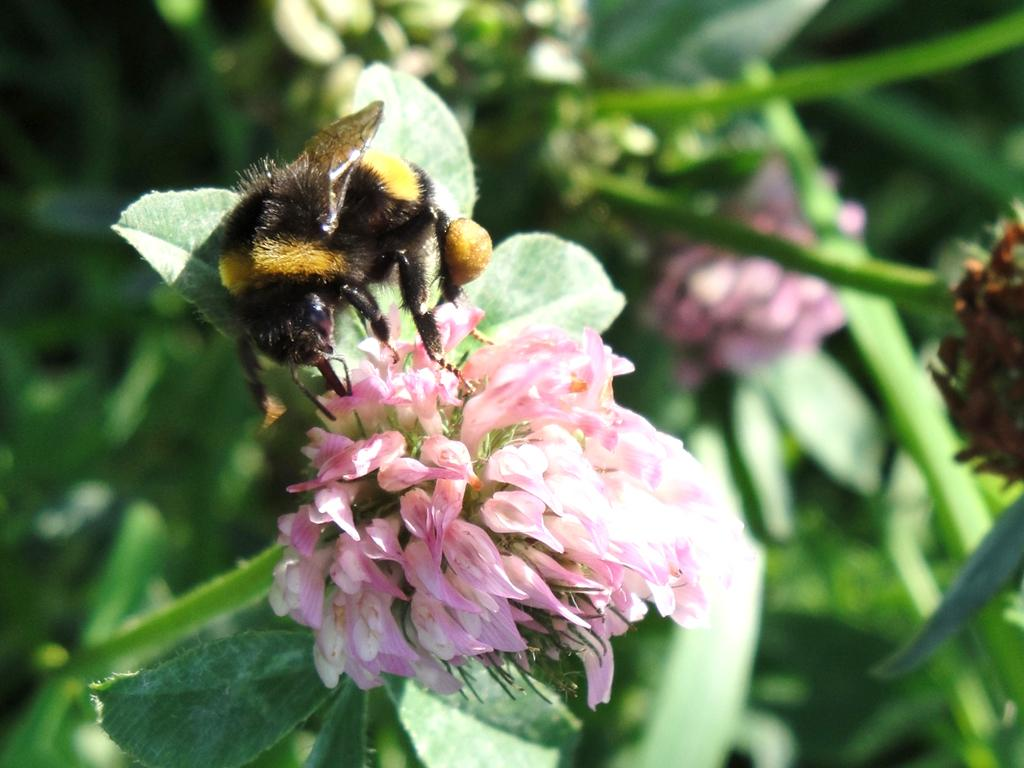What type of plants can be seen in the image? There are flowers and leaves in the image. Is there any animal present in the image? Yes, there is a honey bee on the left side of the image. How would you describe the background of the image? The background of the image is blurry. What is the price of the skirt in the image? There is no skirt present in the image, so it is not possible to determine its price. 